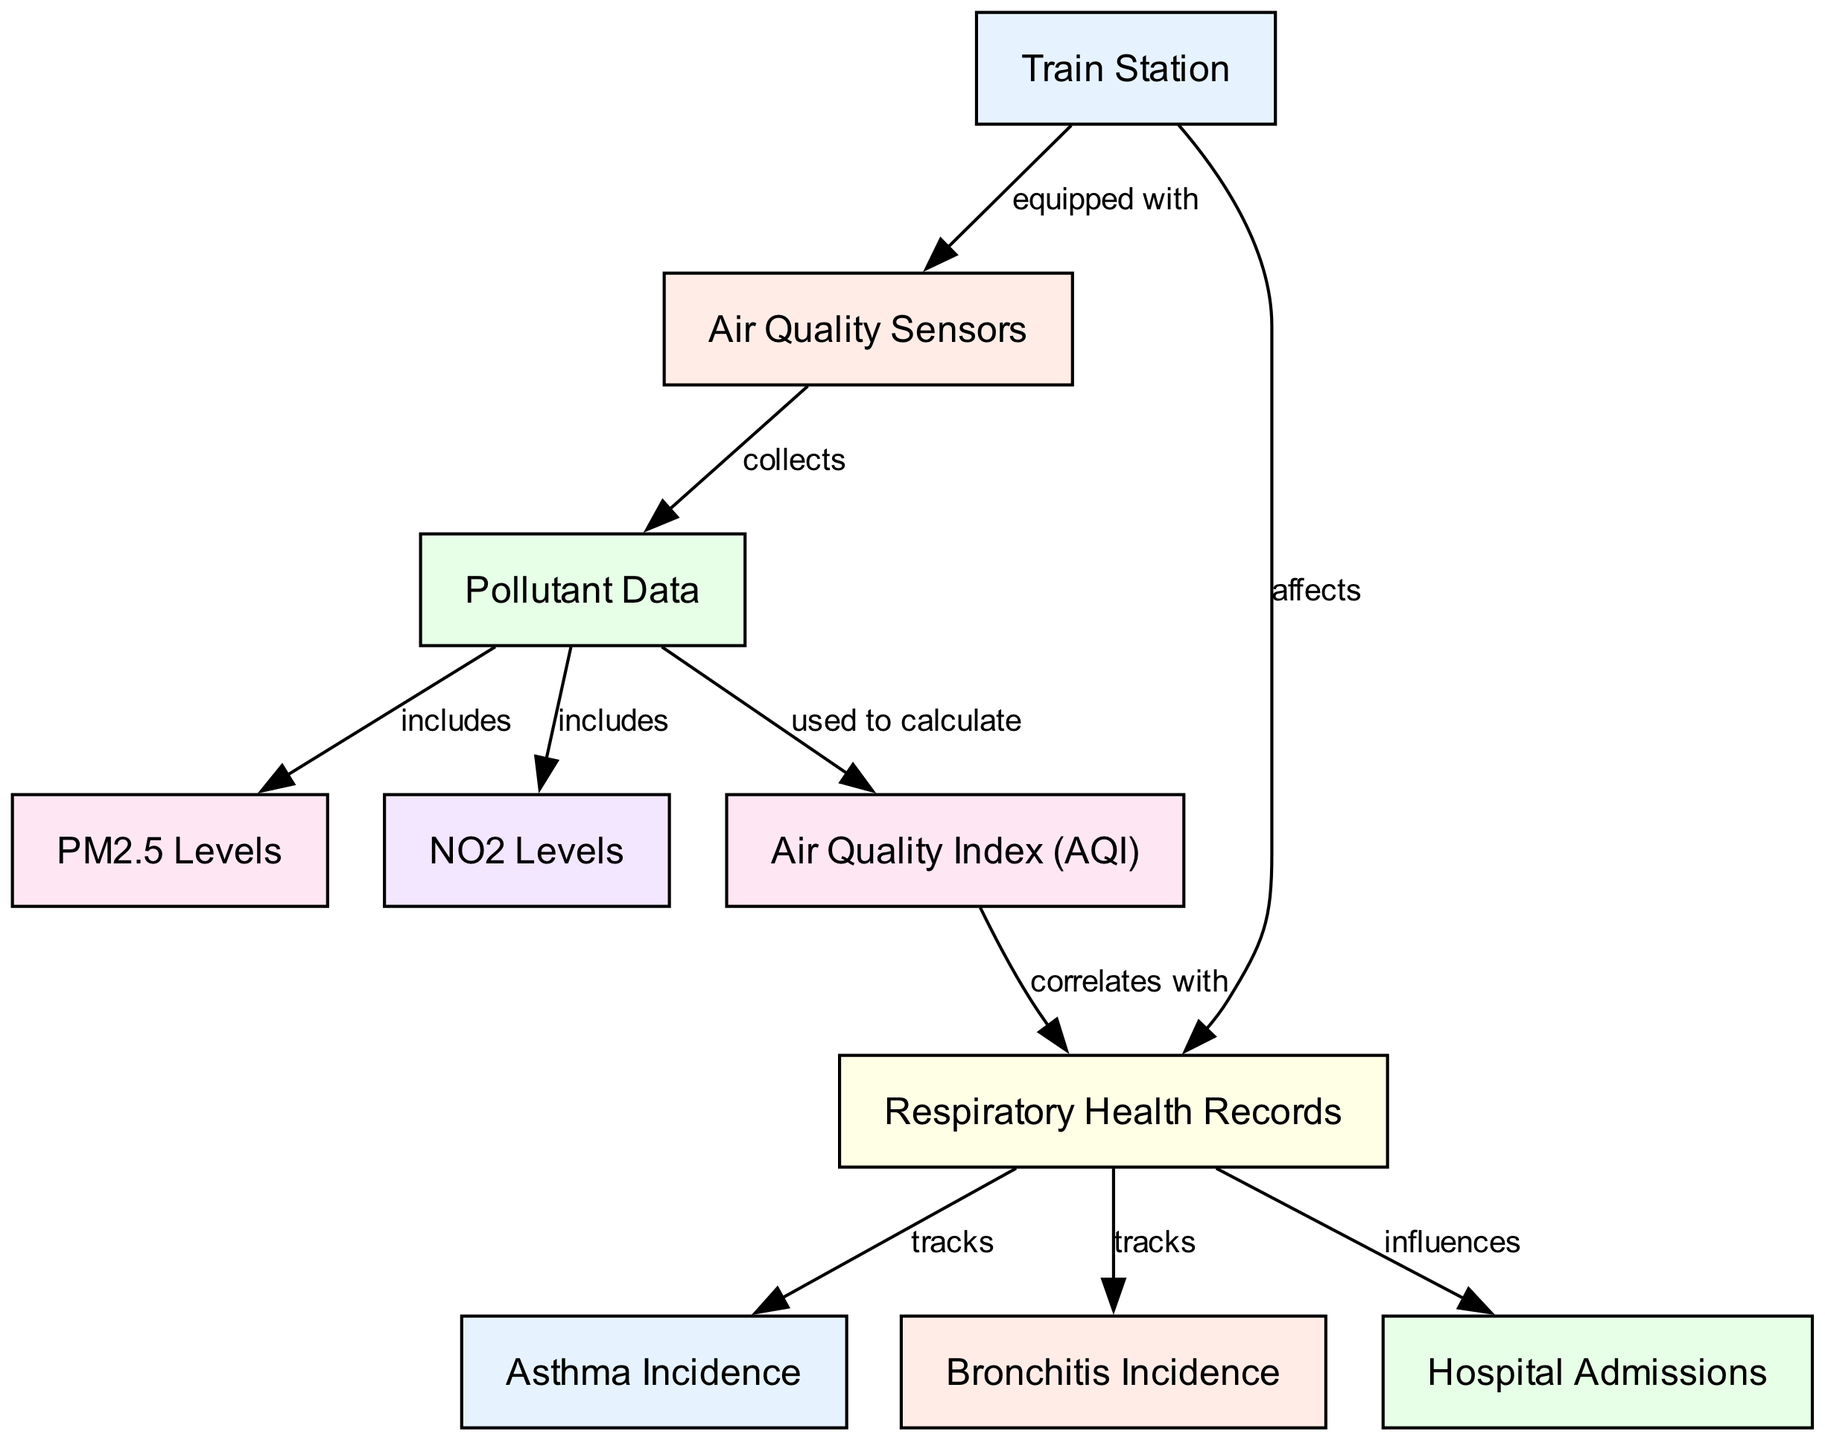What is the first node in the diagram? The first node listed in the data is "Train Station." This is identified by checking the order of nodes in the provided data, where "Train Station" is the first entry.
Answer: Train Station How many edges are there in the diagram? By counting the number of edge objects in the data, there are 10 edges defined between various nodes in the diagram. This is determined by simply tallying the entries under the "edges" section.
Answer: 10 Which node is influenced by Hospital Admissions? The node that "influences" Hospital Admissions is "Respiratory Health Records," as indicated by the label on the corresponding edge from node 6 to node 9.
Answer: Respiratory Health Records What does the Air Quality Index correlate with? The Air Quality Index node correlates with "Respiratory Health Records," as shown by the edge labeled "correlates with" connecting node 10 to node 6.
Answer: Respiratory Health Records How do Train Stations affect respiratory health records? Train Stations directly "affect" respiratory health records, which is indicated by the edge from node 1 to node 6 labeled "affects."
Answer: Respiratory Health Records What pollutants are included in the pollutant data? The pollutants included in the pollutant data are "PM2.5 Levels" and "NO2 Levels," as specifically mentioned by the edges connecting them to node 3 (Pollutant Data).
Answer: PM2.5 Levels, NO2 Levels How does the Air Quality Index relate to the data collected? The Air Quality Index is "used to calculate" based on the pollutants collected by the air quality sensors, which is shown by the edge connecting these nodes. This means that the measurements collected are utilized to derive the AQI.
Answer: Air Quality Sensors What health outcomes are tracked from respiratory health records? The health outcomes tracked from respiratory health records are "Asthma Incidence" and "Bronchitis Incidence," as shown by the connections from node 6 to nodes 7 and 8 respectively.
Answer: Asthma Incidence, Bronchitis Incidence Which node is equipped with air quality sensors? The "Train Station" is the node that is equipped with air quality sensors, as indicated by the edge labeled "equipped with" connecting node 1 to node 2.
Answer: Air Quality Sensors 